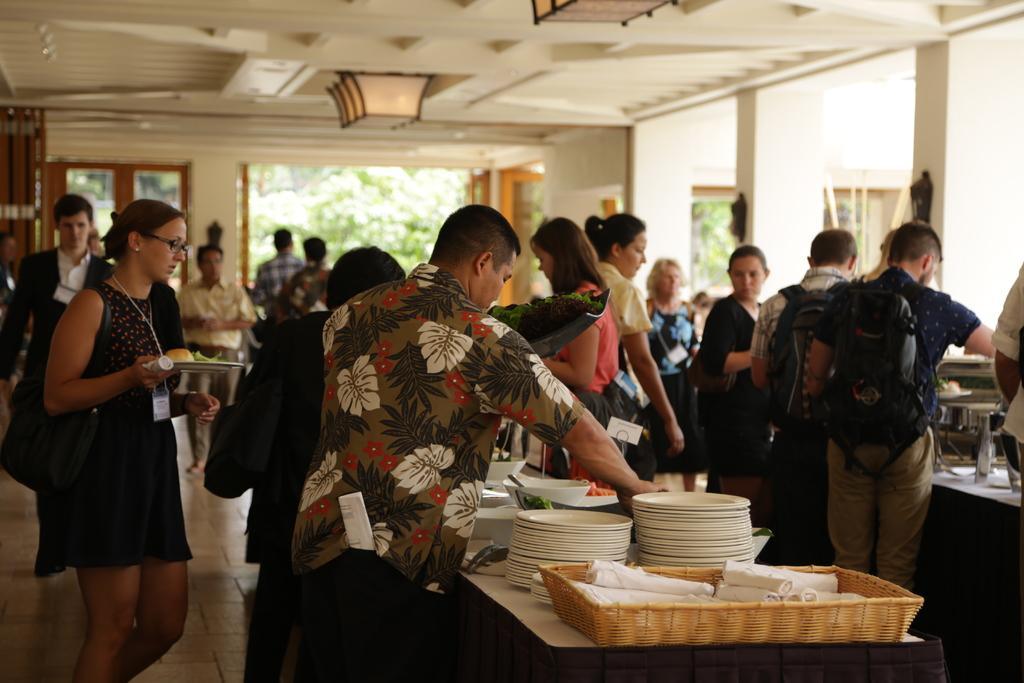In one or two sentences, can you explain what this image depicts? This picture shows a few people standing and serving food in to their plates and we see few plates and food on the table 